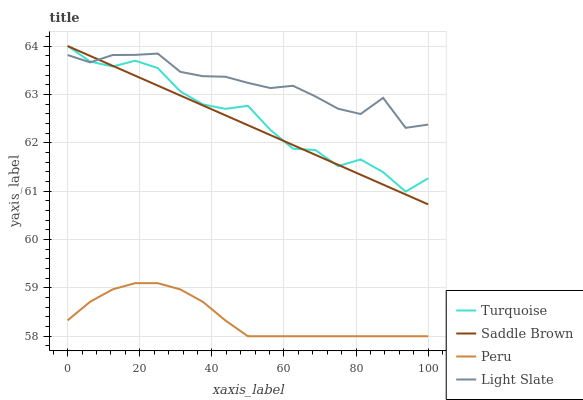Does Peru have the minimum area under the curve?
Answer yes or no. Yes. Does Light Slate have the maximum area under the curve?
Answer yes or no. Yes. Does Turquoise have the minimum area under the curve?
Answer yes or no. No. Does Turquoise have the maximum area under the curve?
Answer yes or no. No. Is Saddle Brown the smoothest?
Answer yes or no. Yes. Is Turquoise the roughest?
Answer yes or no. Yes. Is Turquoise the smoothest?
Answer yes or no. No. Is Saddle Brown the roughest?
Answer yes or no. No. Does Peru have the lowest value?
Answer yes or no. Yes. Does Turquoise have the lowest value?
Answer yes or no. No. Does Saddle Brown have the highest value?
Answer yes or no. Yes. Does Peru have the highest value?
Answer yes or no. No. Is Peru less than Turquoise?
Answer yes or no. Yes. Is Light Slate greater than Peru?
Answer yes or no. Yes. Does Light Slate intersect Turquoise?
Answer yes or no. Yes. Is Light Slate less than Turquoise?
Answer yes or no. No. Is Light Slate greater than Turquoise?
Answer yes or no. No. Does Peru intersect Turquoise?
Answer yes or no. No. 